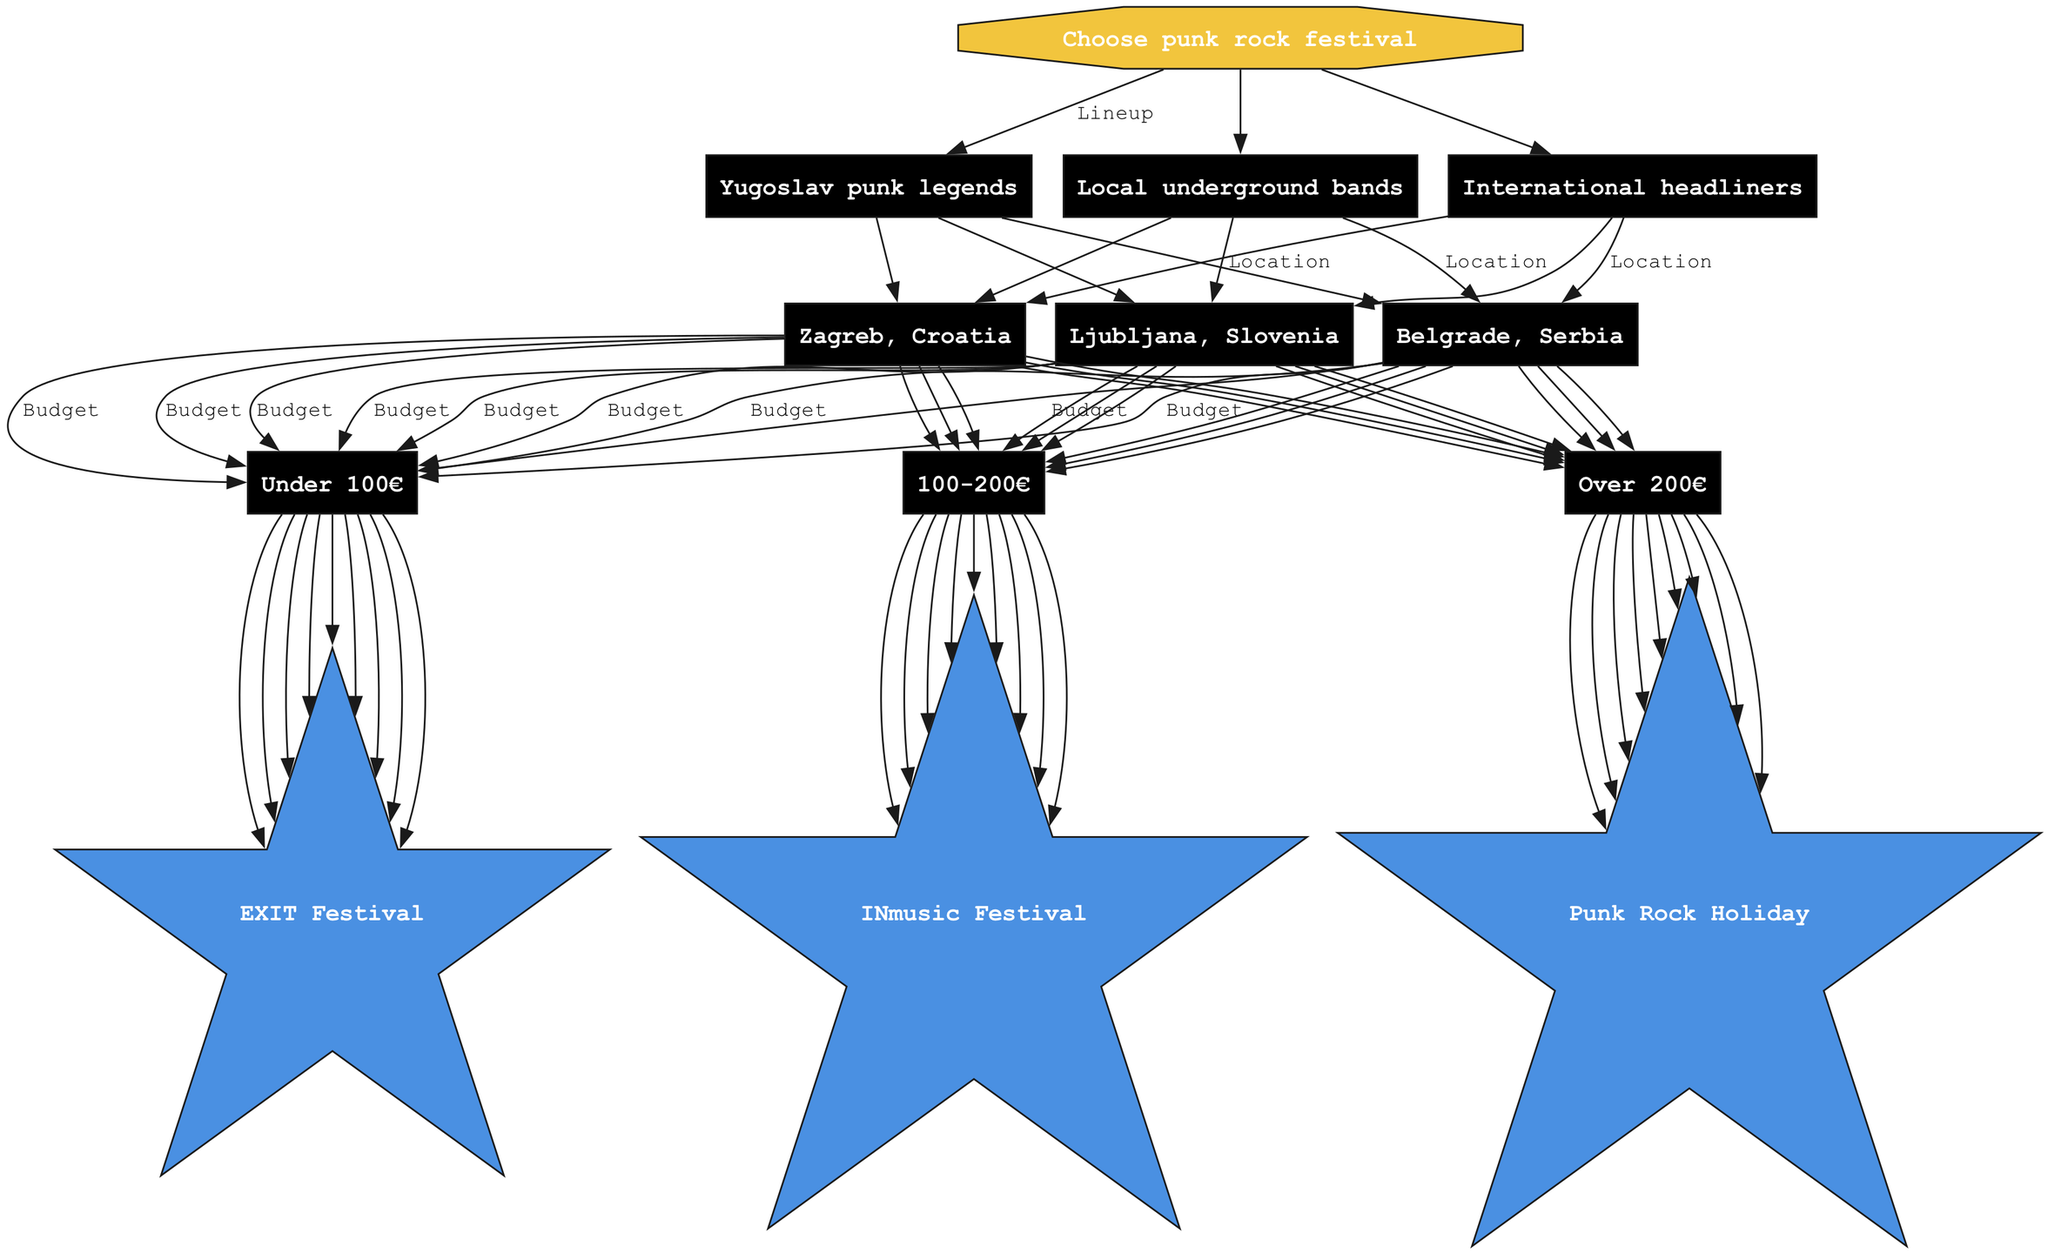What is the first criterion in the decision tree? The first criterion in the decision tree is 'Lineup'. It's the first option branching directly from the root of the diagram.
Answer: Lineup How many festival options are there? The diagram lists three festival options, EXIT Festival, INmusic Festival, and Punk Rock Holiday, which are located at the end of the decision tree branches.
Answer: Three Which festival corresponds to 'Yugoslav punk legends', 'Belgrade, Serbia', and 'Under 100€'? Following the branches from the root, 'Yugoslav punk legends' leads to 'EXIT Festival' when combined with 'Belgrade, Serbia' and 'Under 100€'.
Answer: EXIT Festival What is the budget range for the last festival option? The last festival option, Punk Rock Holiday, is associated with the budget range '100-200€', since this option connects with the last node in that path of the decision tree.
Answer: 100-200€ If someone wants to see local underground bands in Zagreb, which festival should they attend? The path for local underground bands directly connects to 'INmusic Festival', which is held in Zagreb, fulfilling the user's preference and location.
Answer: INmusic Festival How does 'International headliners' influence the choice of festivals? Choosing 'International headliners' leads down the decision tree path resulting in festivals like 'EXIT Festival' and 'Punk Rock Holiday', depending on other criteria like budget and location.
Answer: EXIT Festival, Punk Rock Holiday Which location leads to the maximum number of festival options? Belgrade, Serbia allows access to both 'EXIT Festival' and 'Punk Rock Holiday', maximizing festival options compared to other locations.
Answer: Belgrade, Serbia What is a distinctive feature of the decision tree format used here? A distinctive feature of this decision tree is that it branches out based on three main criteria: Lineup, Location, and Budget, each leading to specific festival options, making it easy to follow the decision-making process.
Answer: Branching criteria 